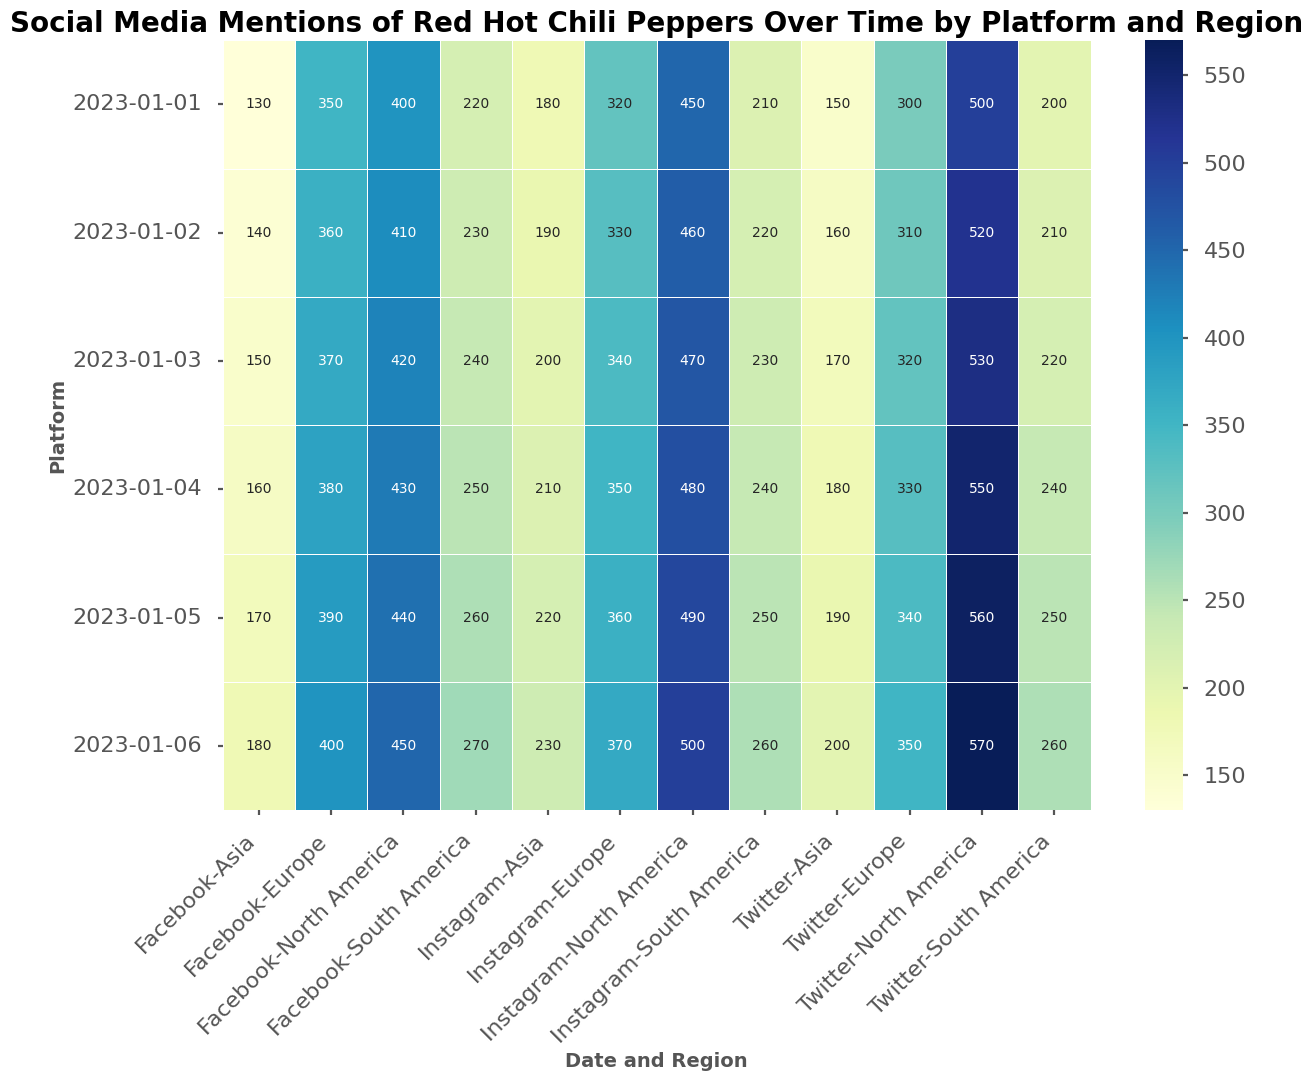How do social media mentions of Red Hot Chili Peppers on Twitter compare between North America and Asia on January 1st, 2023? Refer to the cells for Twitter mentions on January 1st, 2023. North America's mentions are higher than Asia's. Specifically, North America has 500 mentions, while Asia has 150.
Answer: North America has more mentions What is the total number of Facebook mentions for Red Hot Chili Peppers in South America over the period shown? Add up the Facebook mentions from South America across all dates. They are 220, 230, 240, 250, 260, and 270. Adding these gives 220 + 230 + 240 + 250 + 260 + 270 = 1470.
Answer: 1470 On which platform does Asia show the least number of mentions on January 3rd, 2023? Refer to the cells for Asia's mentions on January 3rd, 2023. Twitter has 170, Instagram has 200, and Facebook has 150. The least number of mentions is on Facebook.
Answer: Facebook Which region shows an increasing trend in mentions of Red Hot Chili Peppers on Instagram from January 1st to January 6th, 2023? Compare the counts for each region across the dates for Instagram mentions. North America shows 450, 460, 470, 480, 490, and 500, indicating an increasing trend over time.
Answer: North America What is the difference in the total number of Twitter mentions between North America and Europe from January 1st to January 6th, 2023? Calculate the total Twitter mentions for North America and Europe across all dates. North America: 500 + 520 + 530 + 550 + 560 + 570 = 3230. Europe: 300 + 310 + 320 + 330 + 340 + 350 = 1950. The difference is 3230 - 1950 = 1280.
Answer: 1280 Which date shows the highest number of total mentions across all platforms and regions? Sum the mentions across all platforms and regions for each date. The highest value appears at the end. January 6th has the highest, with 3320 mentions.
Answer: January 6th In which region is the difference between Twitter and Facebook mentions on January 5th, 2023 the smallest? Compare the differences for each region: North America (560-440=120), Europe (340-390=-50), Asia (190-170=20), and South America (250-260=-10). The smallest difference is in South America with -10.
Answer: South America Which platform has the most mentions in Europe on January 1st, 2023? Compare the mentions for each platform in Europe on January 1st, 2023. Twitter has 300, Instagram has 320, and Facebook has 350. Facebook has the highest mentions.
Answer: Facebook What is the average number of Instagram mentions in North America over the dates given? Sum the Instagram mentions in North America and divide by the number of dates. (450 + 460 + 470 + 480 + 490 + 500)/6 = 475.
Answer: 475 